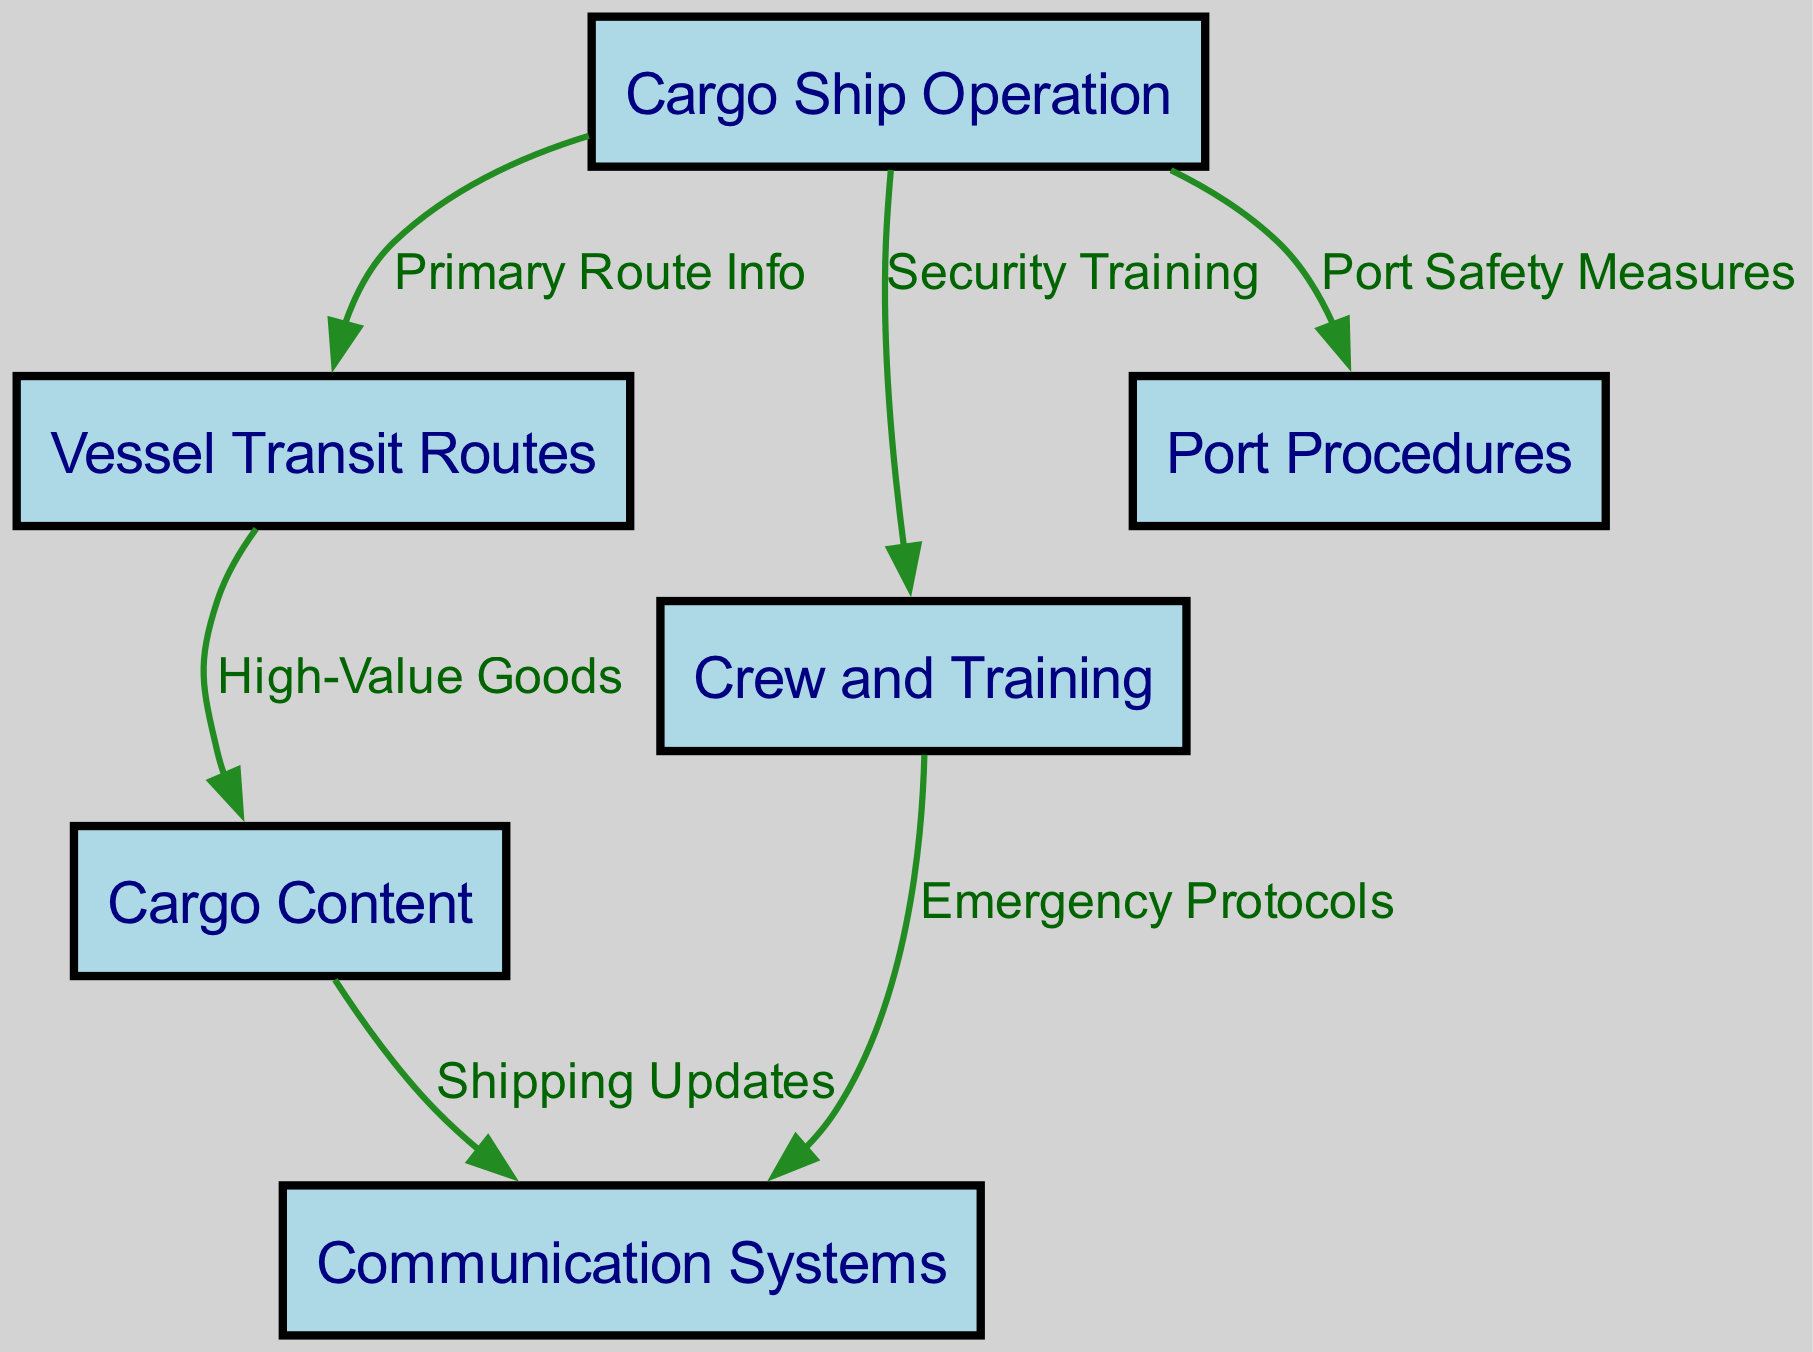What is the total number of nodes in the diagram? The diagram contains several unique elements called nodes. By counting the distinct nodes listed in the data, we find there are six: Cargo Ship Operation, Vessel Transit Routes, Cargo Content, Communication Systems, Crew and Training, and Port Procedures.
Answer: 6 What is the label of the node that deals with high-value goods? In the diagram, the node specifically addressing high-value goods is labeled 'Cargo Content', which indicates that it is associated with the type of goods being transported.
Answer: Cargo Content Which node is directly linked to both Port Procedures and Crew and Training? Analyzing the connections, we see that 'Cargo Ship Operation' is connected to both 'Port Procedures' and 'Crew and Training' directly, as these nodes share edges stemming from it in the diagram.
Answer: Cargo Ship Operation What is the relationship between Cargo Content and Communication Systems? The diagram illustrates a direct relationship where 'Cargo Content' flows updates to 'Communication Systems', indicating that shipping information regarding the cargo affects communication protocols.
Answer: Shipping Updates What is the primary purpose of the Crew and Training node? The node 'Crew and Training' encompasses the aspect of security training as indicated in the diagram. This shows its purpose is to enhance the preparedness of the crew in securing the ship against vulnerabilities.
Answer: Security Training How many edges connect the different nodes in the diagram? By examining the edges, which represent relationships between nodes, we find there are six connections: Cargo Ship Operation to Vessel Transit Routes, Vessel Transit Routes to Cargo Content, Cargo Content to Communication Systems, Cargo Ship Operation to Crew and Training, Crew and Training to Communication Systems, and Cargo Ship Operation to Port Procedures.
Answer: 6 What does the edge from Cargo Ship Operation to Vessel Transit Routes represent? The edge labeled 'Primary Route Info' signifies that the 'Cargo Ship Operation' node provides important information regarding the vessel's specific transit routes, which is crucial for operational planning and security.
Answer: Primary Route Info Which node includes emergency protocols? The node 'Communication Systems' is where emergency protocols are incorporated, as derived from the connection labeled 'Emergency Protocols' stemming from 'Crew and Training', indicating its role in communication during emergencies.
Answer: Communication Systems What would happen if the communication systems had vulnerabilities? If vulnerabilities existed in the communication systems, it would compromise the ability to send shipping updates, potentially leading to uncoordinated responses to threats, enhancing the risk of pirate attacks on the cargo ship.
Answer: Compromised updates 